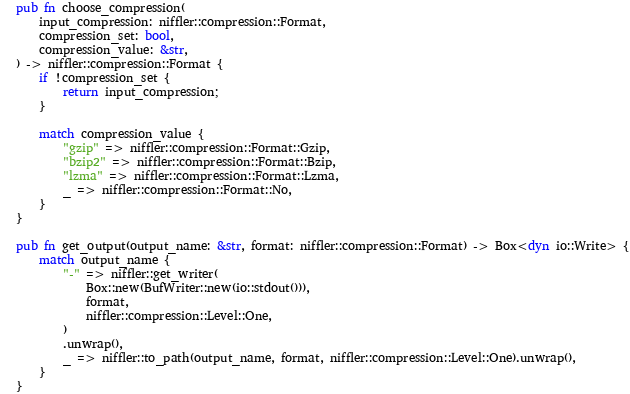<code> <loc_0><loc_0><loc_500><loc_500><_Rust_>pub fn choose_compression(
    input_compression: niffler::compression::Format,
    compression_set: bool,
    compression_value: &str,
) -> niffler::compression::Format {
    if !compression_set {
        return input_compression;
    }

    match compression_value {
        "gzip" => niffler::compression::Format::Gzip,
        "bzip2" => niffler::compression::Format::Bzip,
        "lzma" => niffler::compression::Format::Lzma,
        _ => niffler::compression::Format::No,
    }
}

pub fn get_output(output_name: &str, format: niffler::compression::Format) -> Box<dyn io::Write> {
    match output_name {
        "-" => niffler::get_writer(
            Box::new(BufWriter::new(io::stdout())),
            format,
            niffler::compression::Level::One,
        )
        .unwrap(),
        _ => niffler::to_path(output_name, format, niffler::compression::Level::One).unwrap(),
    }
}
</code> 